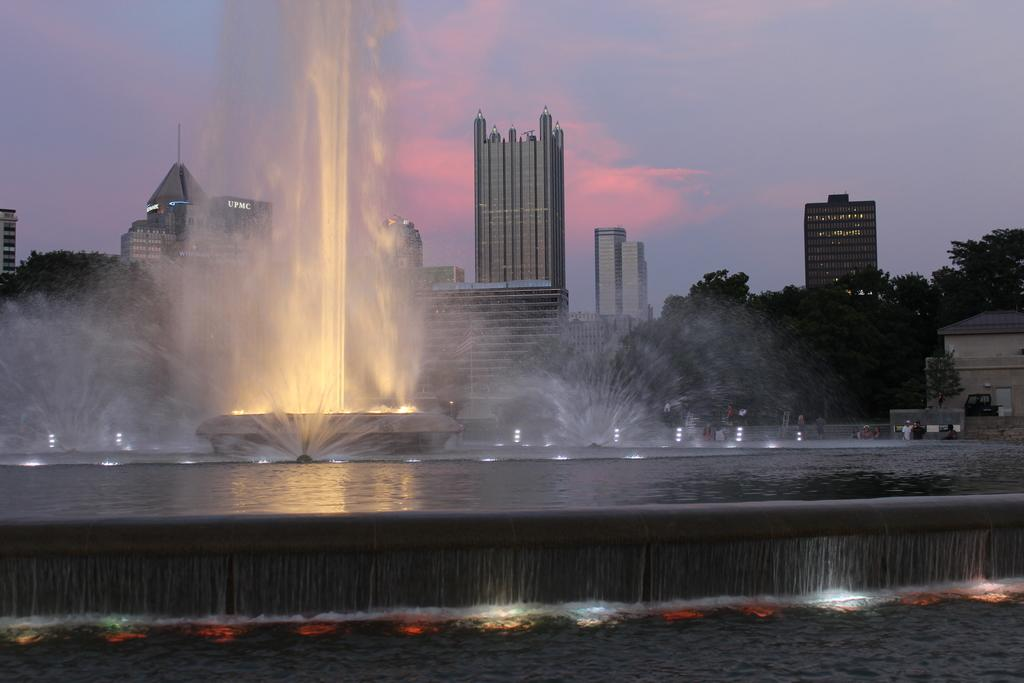What is the primary element visible in the image? There is water in the image. What structures are present in the water? There are fountains in the image. What can be seen in the distance behind the water and fountains? There are trees, buildings, and clouds in the background of the image. What part of the natural environment is visible in the image? The sky is visible in the background of the image. What type of reward can be seen on the list in the image? There is no list or reward present in the image; it features water, fountains, and a background with trees, buildings, clouds, and the sky. 